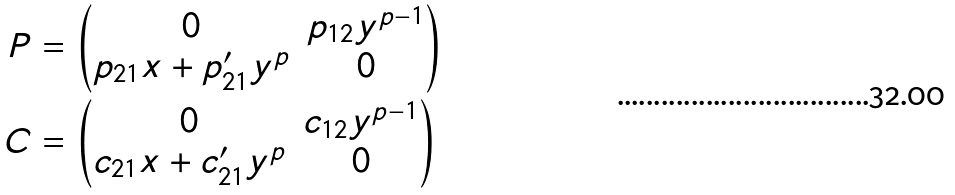<formula> <loc_0><loc_0><loc_500><loc_500>P & = \begin{pmatrix} 0 & p _ { 1 2 } y ^ { p - 1 } \\ p _ { 2 1 } x + p _ { 2 1 } ^ { \prime } y ^ { p } & 0 \end{pmatrix} \\ C & = \begin{pmatrix} 0 & c _ { 1 2 } y ^ { p - 1 } \\ c _ { 2 1 } x + c _ { 2 1 } ^ { \prime } y ^ { p } & 0 \end{pmatrix}</formula> 